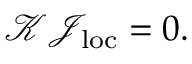Convert formula to latex. <formula><loc_0><loc_0><loc_500><loc_500>\begin{array} { r } { \mathcal { K } \mathcal { J } _ { l o c } = 0 . } \end{array}</formula> 